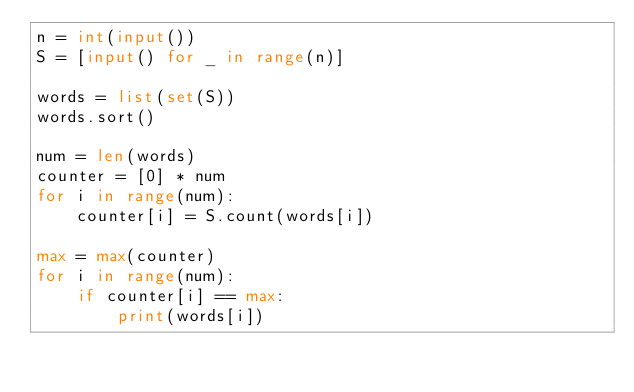<code> <loc_0><loc_0><loc_500><loc_500><_Python_>n = int(input())
S = [input() for _ in range(n)]

words = list(set(S))
words.sort()

num = len(words)
counter = [0] * num
for i in range(num):
    counter[i] = S.count(words[i])

max = max(counter)
for i in range(num):
    if counter[i] == max:
        print(words[i])</code> 